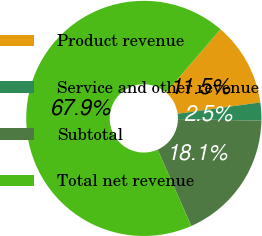<chart> <loc_0><loc_0><loc_500><loc_500><pie_chart><fcel>Product revenue<fcel>Service and other revenue<fcel>Subtotal<fcel>Total net revenue<nl><fcel>11.53%<fcel>2.48%<fcel>18.07%<fcel>67.92%<nl></chart> 